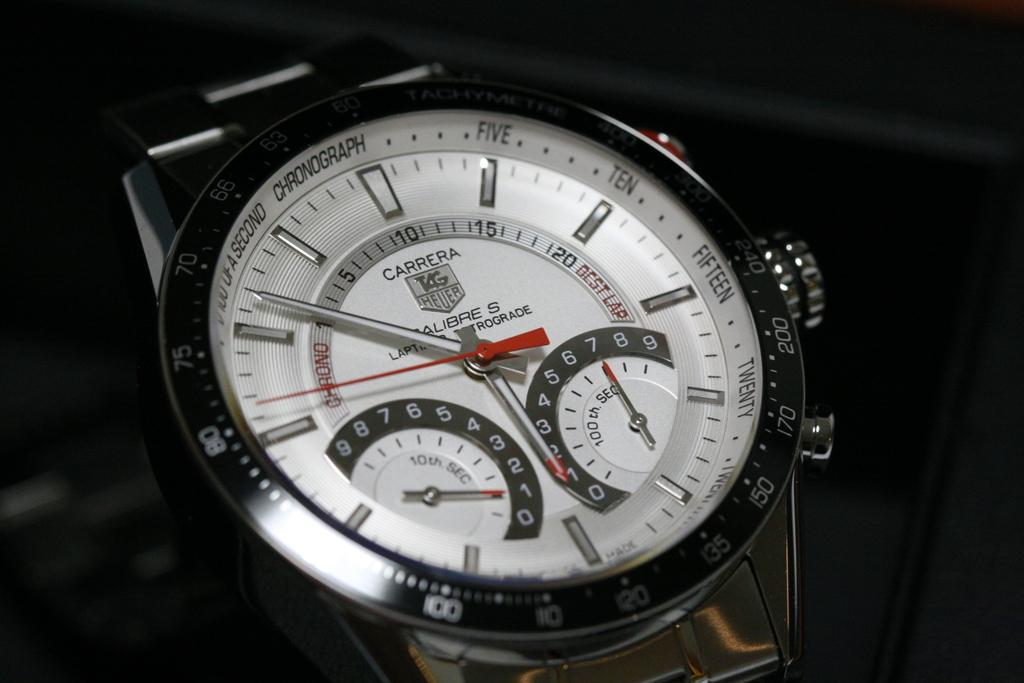<image>
Relay a brief, clear account of the picture shown. A Carrera silver watch with 5:53 on the face. 